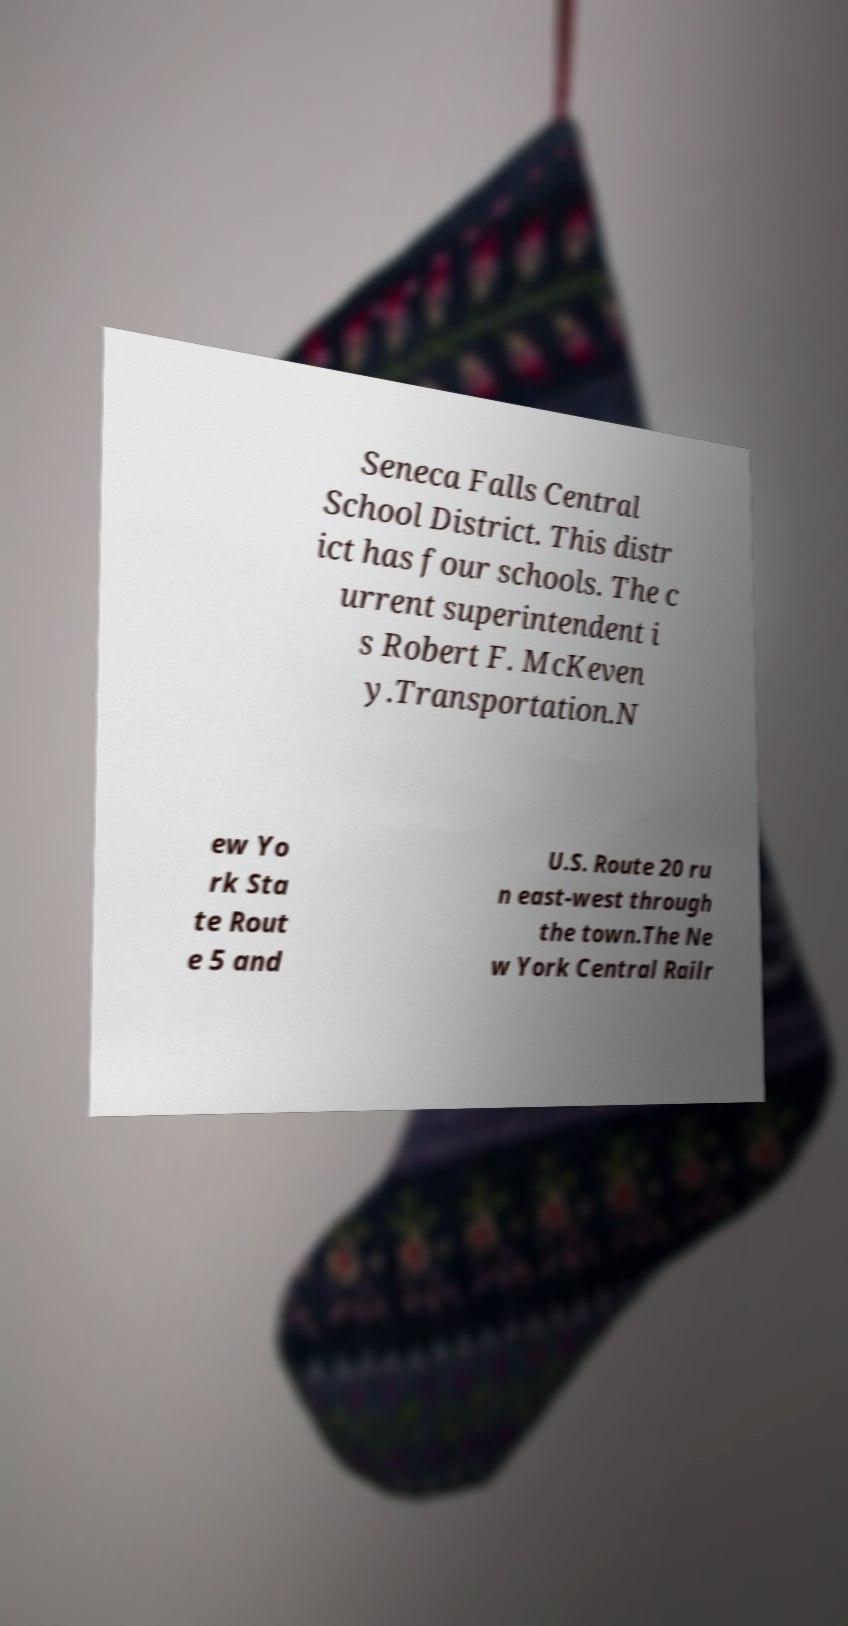Could you extract and type out the text from this image? Seneca Falls Central School District. This distr ict has four schools. The c urrent superintendent i s Robert F. McKeven y.Transportation.N ew Yo rk Sta te Rout e 5 and U.S. Route 20 ru n east-west through the town.The Ne w York Central Railr 